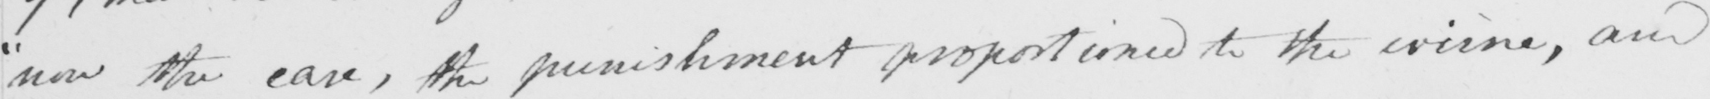Please transcribe the handwritten text in this image. " now the case , the punishment proportioned to the crime , and 